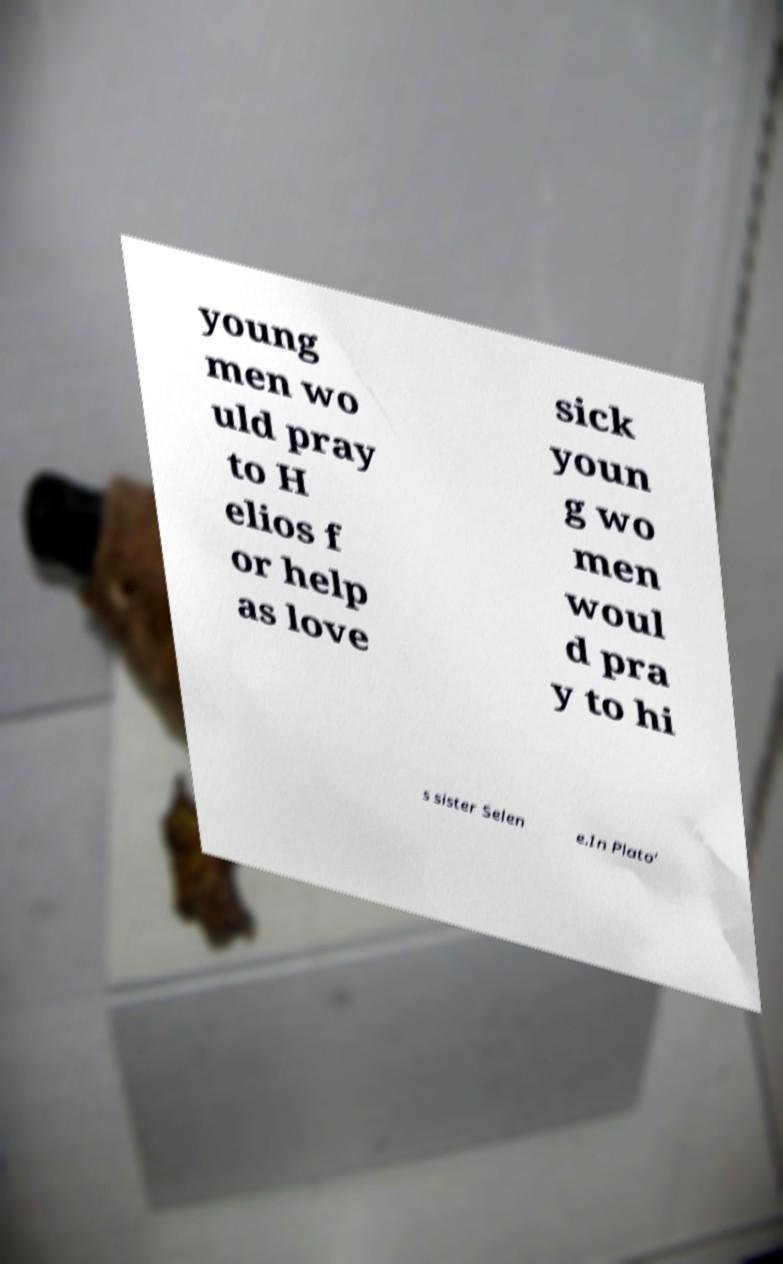For documentation purposes, I need the text within this image transcribed. Could you provide that? young men wo uld pray to H elios f or help as love sick youn g wo men woul d pra y to hi s sister Selen e.In Plato' 